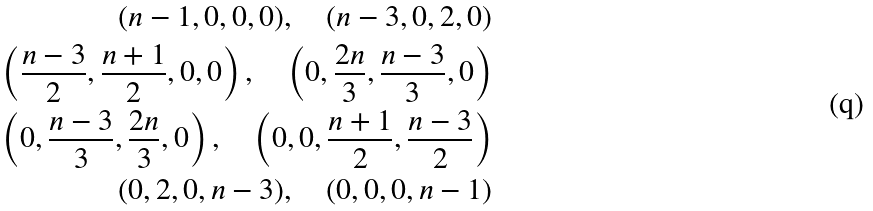<formula> <loc_0><loc_0><loc_500><loc_500>( n - 1 , 0 , 0 , 0 ) , \quad ( n - 3 , 0 , 2 , 0 ) \\ \left ( \frac { n - 3 } 2 , \frac { n + 1 } 2 , 0 , 0 \right ) , \quad \left ( 0 , \frac { 2 n } { 3 } , \frac { n - 3 } { 3 } , 0 \right ) \\ \left ( 0 , \frac { n - 3 } { 3 } , \frac { 2 n } { 3 } , 0 \right ) , \quad \left ( 0 , 0 , \frac { n + 1 } 2 , \frac { n - 3 } 2 \right ) \\ ( 0 , 2 , 0 , n - 3 ) , \quad ( 0 , 0 , 0 , n - 1 )</formula> 